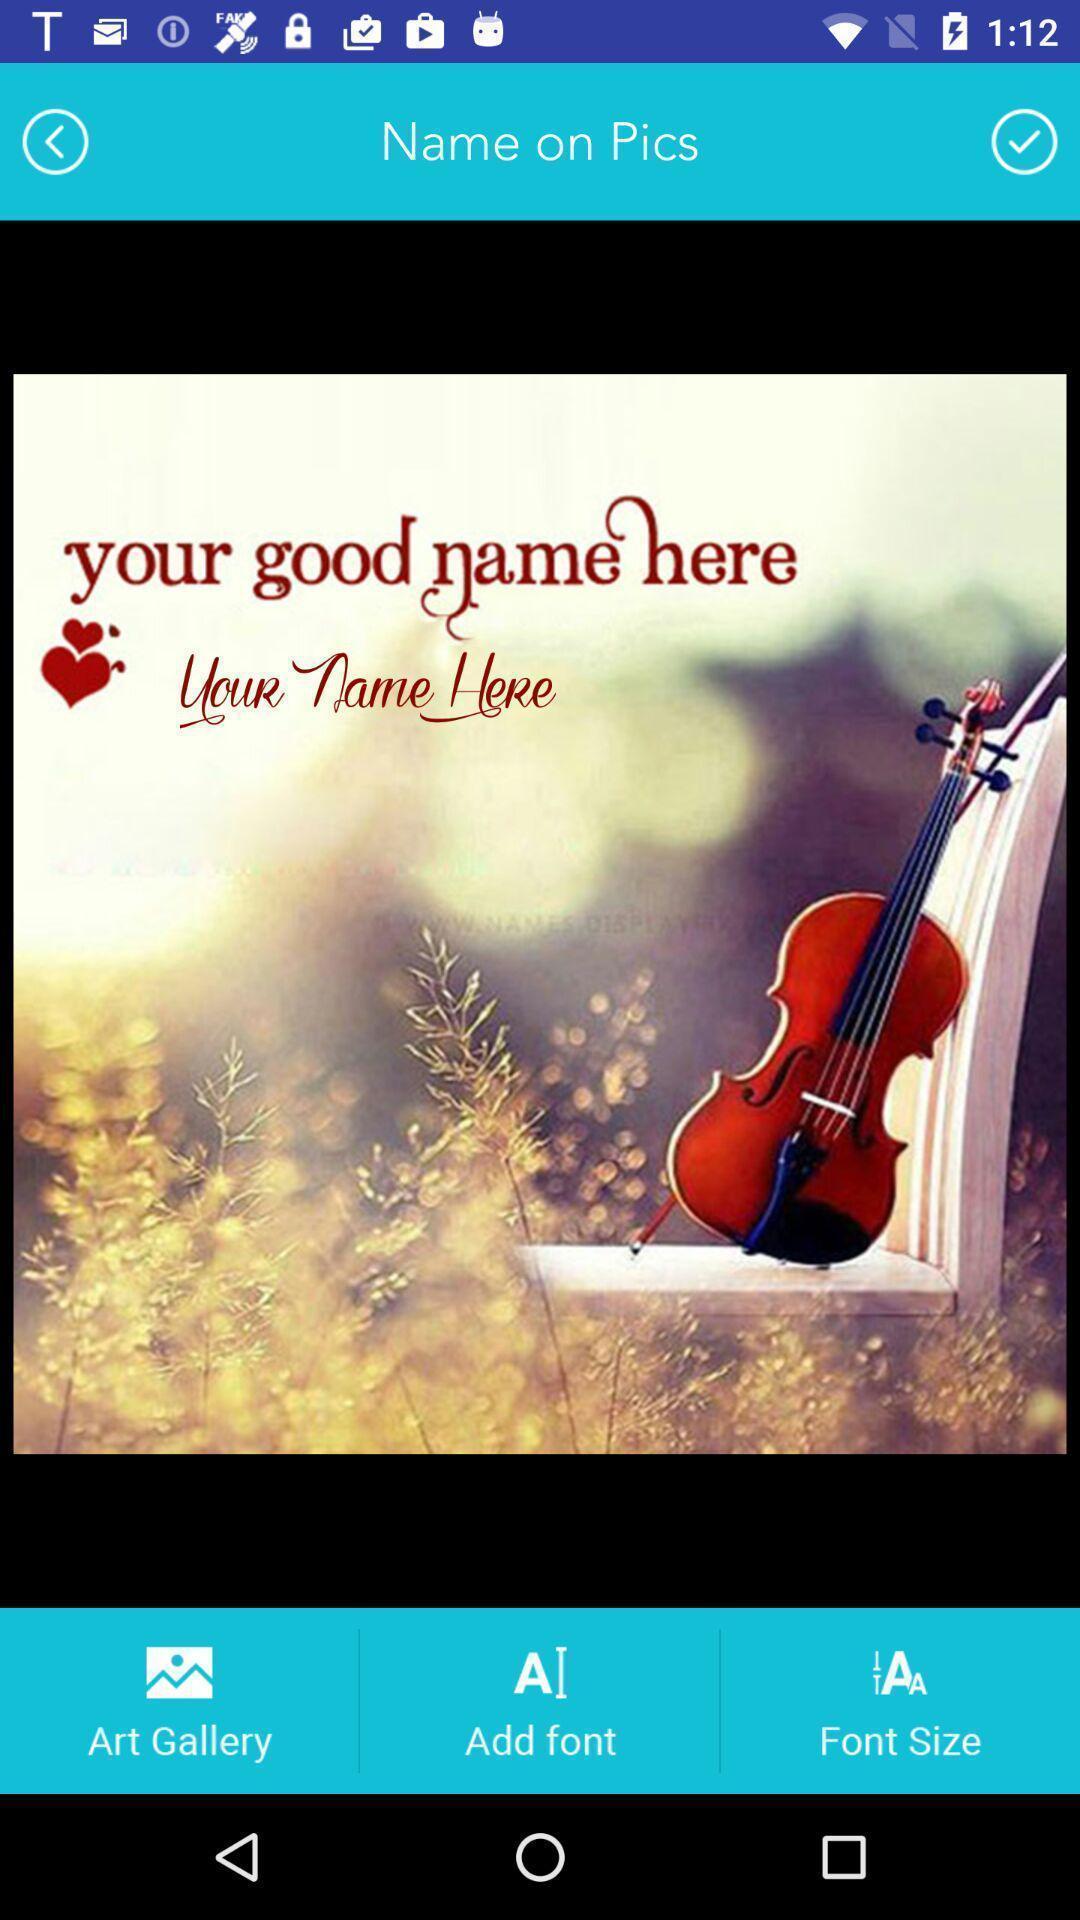Please provide a description for this image. Page to add a name on the pics. 